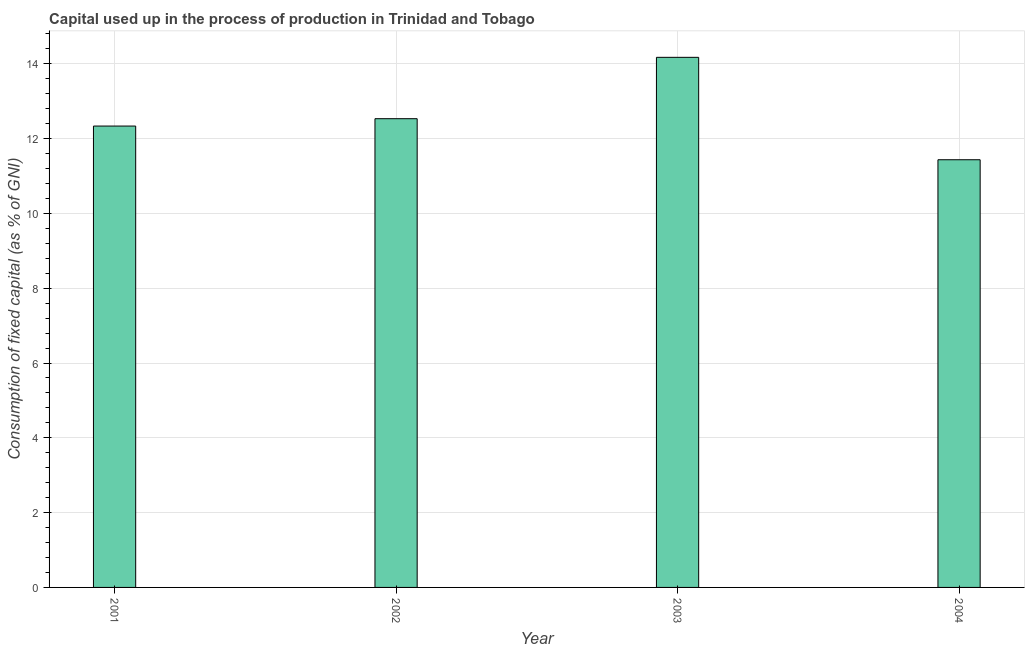Does the graph contain any zero values?
Provide a short and direct response. No. What is the title of the graph?
Ensure brevity in your answer.  Capital used up in the process of production in Trinidad and Tobago. What is the label or title of the Y-axis?
Offer a terse response. Consumption of fixed capital (as % of GNI). What is the consumption of fixed capital in 2003?
Your answer should be very brief. 14.17. Across all years, what is the maximum consumption of fixed capital?
Provide a short and direct response. 14.17. Across all years, what is the minimum consumption of fixed capital?
Offer a terse response. 11.44. What is the sum of the consumption of fixed capital?
Provide a succinct answer. 50.48. What is the difference between the consumption of fixed capital in 2001 and 2004?
Your answer should be compact. 0.9. What is the average consumption of fixed capital per year?
Keep it short and to the point. 12.62. What is the median consumption of fixed capital?
Offer a very short reply. 12.43. What is the ratio of the consumption of fixed capital in 2003 to that in 2004?
Your response must be concise. 1.24. Is the difference between the consumption of fixed capital in 2001 and 2004 greater than the difference between any two years?
Give a very brief answer. No. What is the difference between the highest and the second highest consumption of fixed capital?
Provide a short and direct response. 1.64. What is the difference between the highest and the lowest consumption of fixed capital?
Offer a terse response. 2.74. In how many years, is the consumption of fixed capital greater than the average consumption of fixed capital taken over all years?
Provide a short and direct response. 1. Are all the bars in the graph horizontal?
Provide a succinct answer. No. What is the difference between two consecutive major ticks on the Y-axis?
Provide a succinct answer. 2. What is the Consumption of fixed capital (as % of GNI) in 2001?
Your answer should be very brief. 12.34. What is the Consumption of fixed capital (as % of GNI) in 2002?
Give a very brief answer. 12.53. What is the Consumption of fixed capital (as % of GNI) in 2003?
Offer a very short reply. 14.17. What is the Consumption of fixed capital (as % of GNI) in 2004?
Provide a short and direct response. 11.44. What is the difference between the Consumption of fixed capital (as % of GNI) in 2001 and 2002?
Provide a short and direct response. -0.2. What is the difference between the Consumption of fixed capital (as % of GNI) in 2001 and 2003?
Keep it short and to the point. -1.84. What is the difference between the Consumption of fixed capital (as % of GNI) in 2001 and 2004?
Provide a short and direct response. 0.9. What is the difference between the Consumption of fixed capital (as % of GNI) in 2002 and 2003?
Offer a terse response. -1.64. What is the difference between the Consumption of fixed capital (as % of GNI) in 2002 and 2004?
Ensure brevity in your answer.  1.1. What is the difference between the Consumption of fixed capital (as % of GNI) in 2003 and 2004?
Your answer should be very brief. 2.74. What is the ratio of the Consumption of fixed capital (as % of GNI) in 2001 to that in 2002?
Offer a terse response. 0.98. What is the ratio of the Consumption of fixed capital (as % of GNI) in 2001 to that in 2003?
Keep it short and to the point. 0.87. What is the ratio of the Consumption of fixed capital (as % of GNI) in 2001 to that in 2004?
Provide a succinct answer. 1.08. What is the ratio of the Consumption of fixed capital (as % of GNI) in 2002 to that in 2003?
Offer a very short reply. 0.88. What is the ratio of the Consumption of fixed capital (as % of GNI) in 2002 to that in 2004?
Provide a succinct answer. 1.1. What is the ratio of the Consumption of fixed capital (as % of GNI) in 2003 to that in 2004?
Offer a terse response. 1.24. 